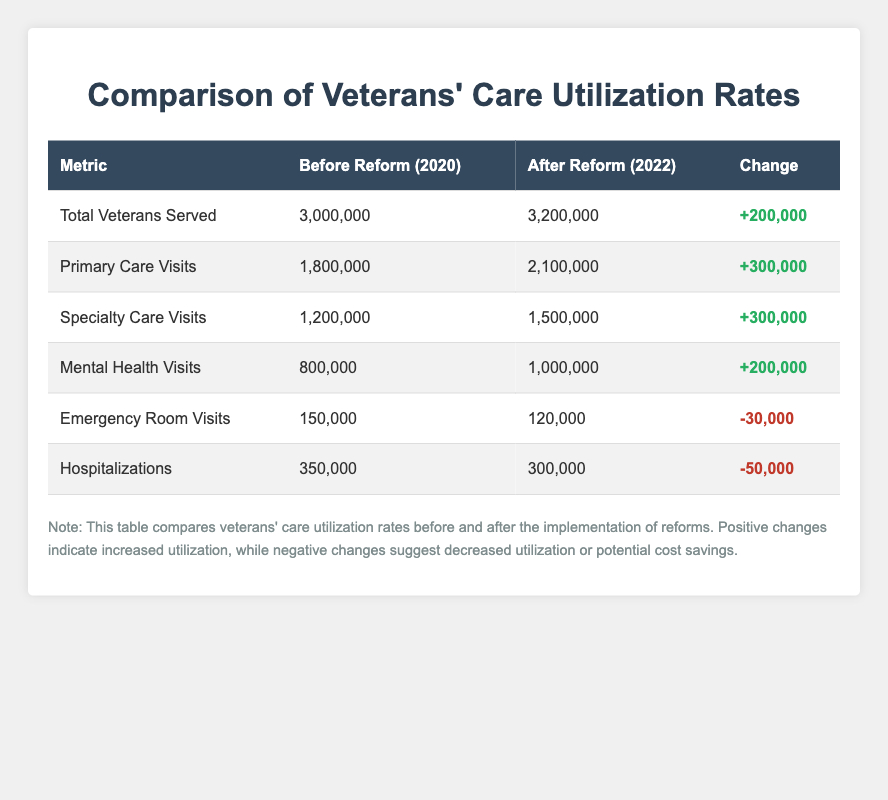What were the total veterans served before the reform? The table shows that in the year 2020, which is before the reform, the total veterans served were 3,000,000.
Answer: 3,000,000 What change occurred in primary care visits after the reform? The table indicates that primary care visits increased from 1,800,000 before the reform to 2,100,000 after the reform, which is a change of +300,000.
Answer: +300,000 Did emergency room visits increase or decrease after the reform? The table shows that emergency room visits decreased from 150,000 before the reform to 120,000 after the reform, indicating a decline in utilization.
Answer: Decrease What is the total change in hospitalizations from before to after the reform? From the table, hospitalizations dropped from 350,000 before the reform to 300,000 after the reform. The change calculated is 350,000 - 300,000 = -50,000.
Answer: -50,000 What percentage of the total veterans served in 2020 were mental health visits? To find the percentage of mental health visits in 2020, we take 800,000 (mental health visits) and divide it by 3,000,000 (total veterans served), then multiply by 100. This results in (800,000 / 3,000,000) * 100 = 26.67%.
Answer: 26.67% If primary care visits and specialty care visits are combined, what is their total after the reform? After the reform, primary care visits are 2,100,000 and specialty care visits are 1,500,000. To get the combined total, we add the two: 2,100,000 + 1,500,000 = 3,600,000.
Answer: 3,600,000 Was there an increase in the number of veterans served from before to after the reform? Yes, the total veterans served increased from 3,000,000 before the reform to 3,200,000 after the reform, indicating an increase of 200,000.
Answer: Yes What was the total change in mental health visits following the reform? The table shows that mental health visits increased from 800,000 to 1,000,000, which represents a total change of +200,000.
Answer: +200,000 